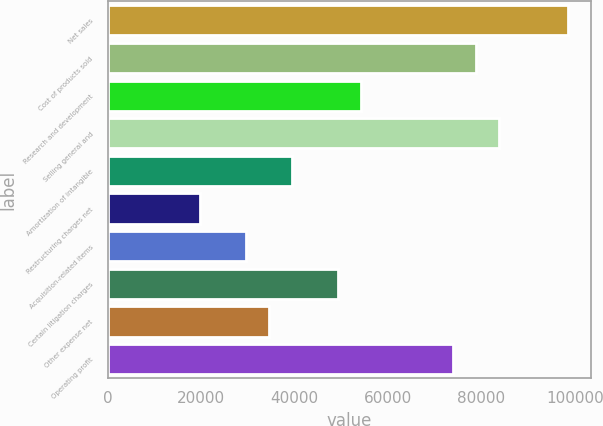Convert chart. <chart><loc_0><loc_0><loc_500><loc_500><bar_chart><fcel>Net sales<fcel>Cost of products sold<fcel>Research and development<fcel>Selling general and<fcel>Amortization of intangible<fcel>Restructuring charges net<fcel>Acquisition-related items<fcel>Certain litigation charges<fcel>Other expense net<fcel>Operating profit<nl><fcel>98492.9<fcel>78794.6<fcel>54171.6<fcel>83719.1<fcel>39397.8<fcel>19699.5<fcel>29548.7<fcel>49247<fcel>34473.2<fcel>73870<nl></chart> 